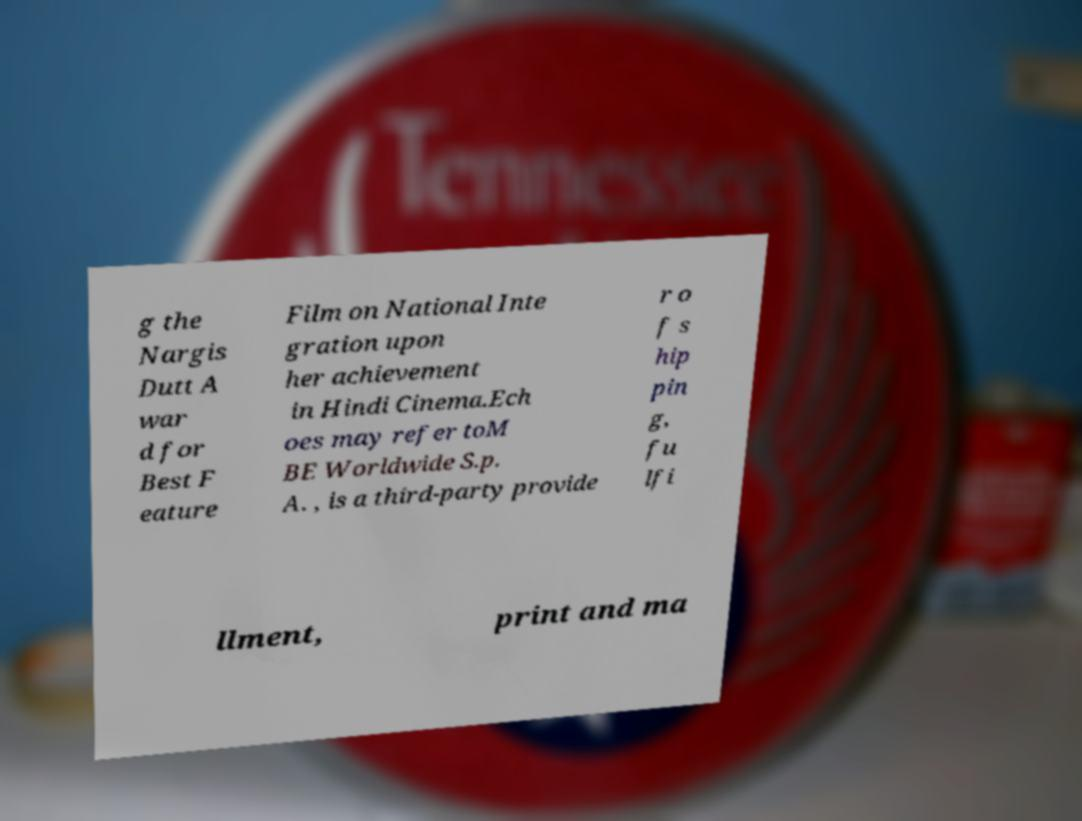There's text embedded in this image that I need extracted. Can you transcribe it verbatim? g the Nargis Dutt A war d for Best F eature Film on National Inte gration upon her achievement in Hindi Cinema.Ech oes may refer toM BE Worldwide S.p. A. , is a third-party provide r o f s hip pin g, fu lfi llment, print and ma 